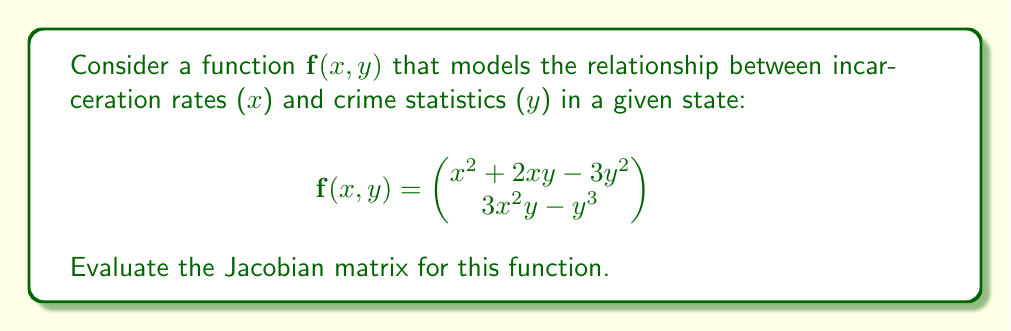Could you help me with this problem? To evaluate the Jacobian matrix, we need to compute the partial derivatives of each component of the function with respect to each variable.

The Jacobian matrix $J$ for a function $\mathbf{f}(x, y)$ with two components $f_1(x, y)$ and $f_2(x, y)$ is defined as:

$$J = \begin{bmatrix}
\frac{\partial f_1}{\partial x} & \frac{\partial f_1}{\partial y} \\
\frac{\partial f_2}{\partial x} & \frac{\partial f_2}{\partial y}
\end{bmatrix}$$

Let's compute each partial derivative:

1. $\frac{\partial f_1}{\partial x} = \frac{\partial}{\partial x}(x^2 + 2xy - 3y^2) = 2x + 2y$

2. $\frac{\partial f_1}{\partial y} = \frac{\partial}{\partial y}(x^2 + 2xy - 3y^2) = 2x - 6y$

3. $\frac{\partial f_2}{\partial x} = \frac{\partial}{\partial x}(3x^2y - y^3) = 6xy$

4. $\frac{\partial f_2}{\partial y} = \frac{\partial}{\partial y}(3x^2y - y^3) = 3x^2 - 3y^2$

Now, we can construct the Jacobian matrix:

$$J = \begin{bmatrix}
2x + 2y & 2x - 6y \\
6xy & 3x^2 - 3y^2
\end{bmatrix}$$
Answer: $$J = \begin{bmatrix}
2x + 2y & 2x - 6y \\
6xy & 3x^2 - 3y^2
\end{bmatrix}$$ 